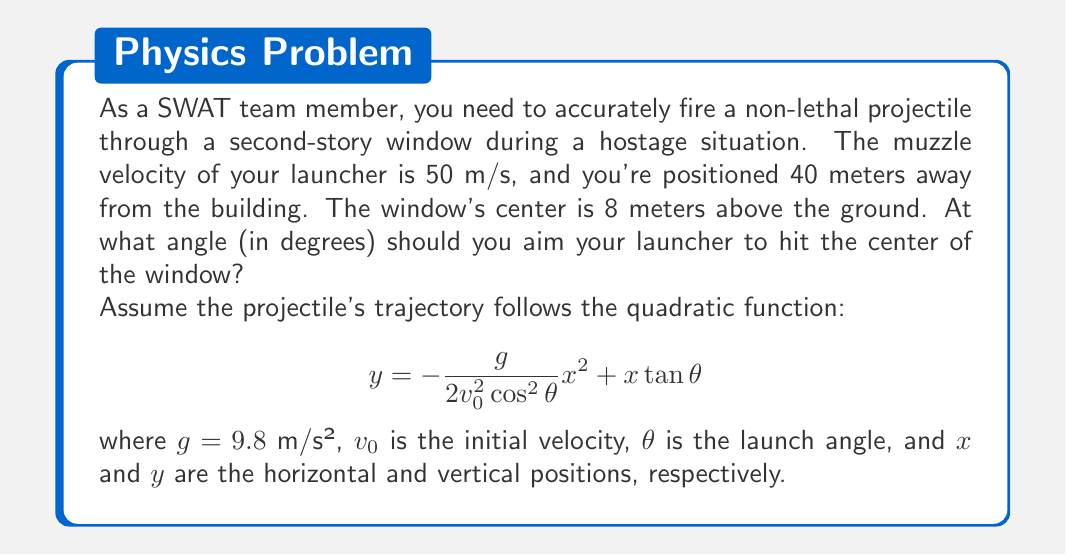Give your solution to this math problem. Let's approach this step-by-step:

1) We know that the projectile needs to hit a point (x, y) = (40, 8).

2) Substituting these values into the quadratic function:

   $$8 = -\frac{9.8}{2(50)^2\cos^2\theta}(40)^2 + 40\tan\theta$$

3) Simplify the constant term:

   $$8 = -\frac{9.8 \cdot 1600}{5000\cos^2\theta} + 40\tan\theta$$

   $$8 = -\frac{3.136}{\cos^2\theta} + 40\tan\theta$$

4) Multiply both sides by $\cos^2\theta$:

   $$8\cos^2\theta = -3.136 + 40\sin\theta\cos\theta$$

5) Substitute $\sin\theta = \frac{\sqrt{1-\cos^2\theta}}{\cos\theta}$:

   $$8\cos^2\theta = -3.136 + 40\sqrt{1-\cos^2\theta}$$

6) Let $u = \cos\theta$. Then our equation becomes:

   $$8u^2 = -3.136 + 40\sqrt{1-u^2}$$

7) Rearrange:

   $$40\sqrt{1-u^2} = 8u^2 + 3.136$$

8) Square both sides:

   $$1600(1-u^2) = 64u^4 + 50.176u^2 + 9.834496$$

9) Expand and rearrange:

   $$64u^4 + 1650.176u^2 - 1590.165504 = 0$$

10) This is a quadratic in $u^2$. Solve using the quadratic formula:

    $$u^2 = \frac{-1650.176 \pm \sqrt{1650.176^2 + 4 \cdot 64 \cdot 1590.165504}}{2 \cdot 64}$$

11) Solving this gives $u^2 \approx 0.7161$ or $u^2 \approx -6.4465$

12) Since $u = \cos\theta$, we can discard the negative solution. So:

    $$\cos\theta \approx \sqrt{0.7161} \approx 0.8463$$

13) Therefore:

    $$\theta = \arccos(0.8463) \approx 0.5575 \text{ radians}$$

14) Convert to degrees:

    $$\theta \approx 0.5575 \cdot \frac{180}{\pi} \approx 31.94°$$
Answer: The SWAT team member should aim the launcher at an angle of approximately 31.94 degrees above the horizontal. 